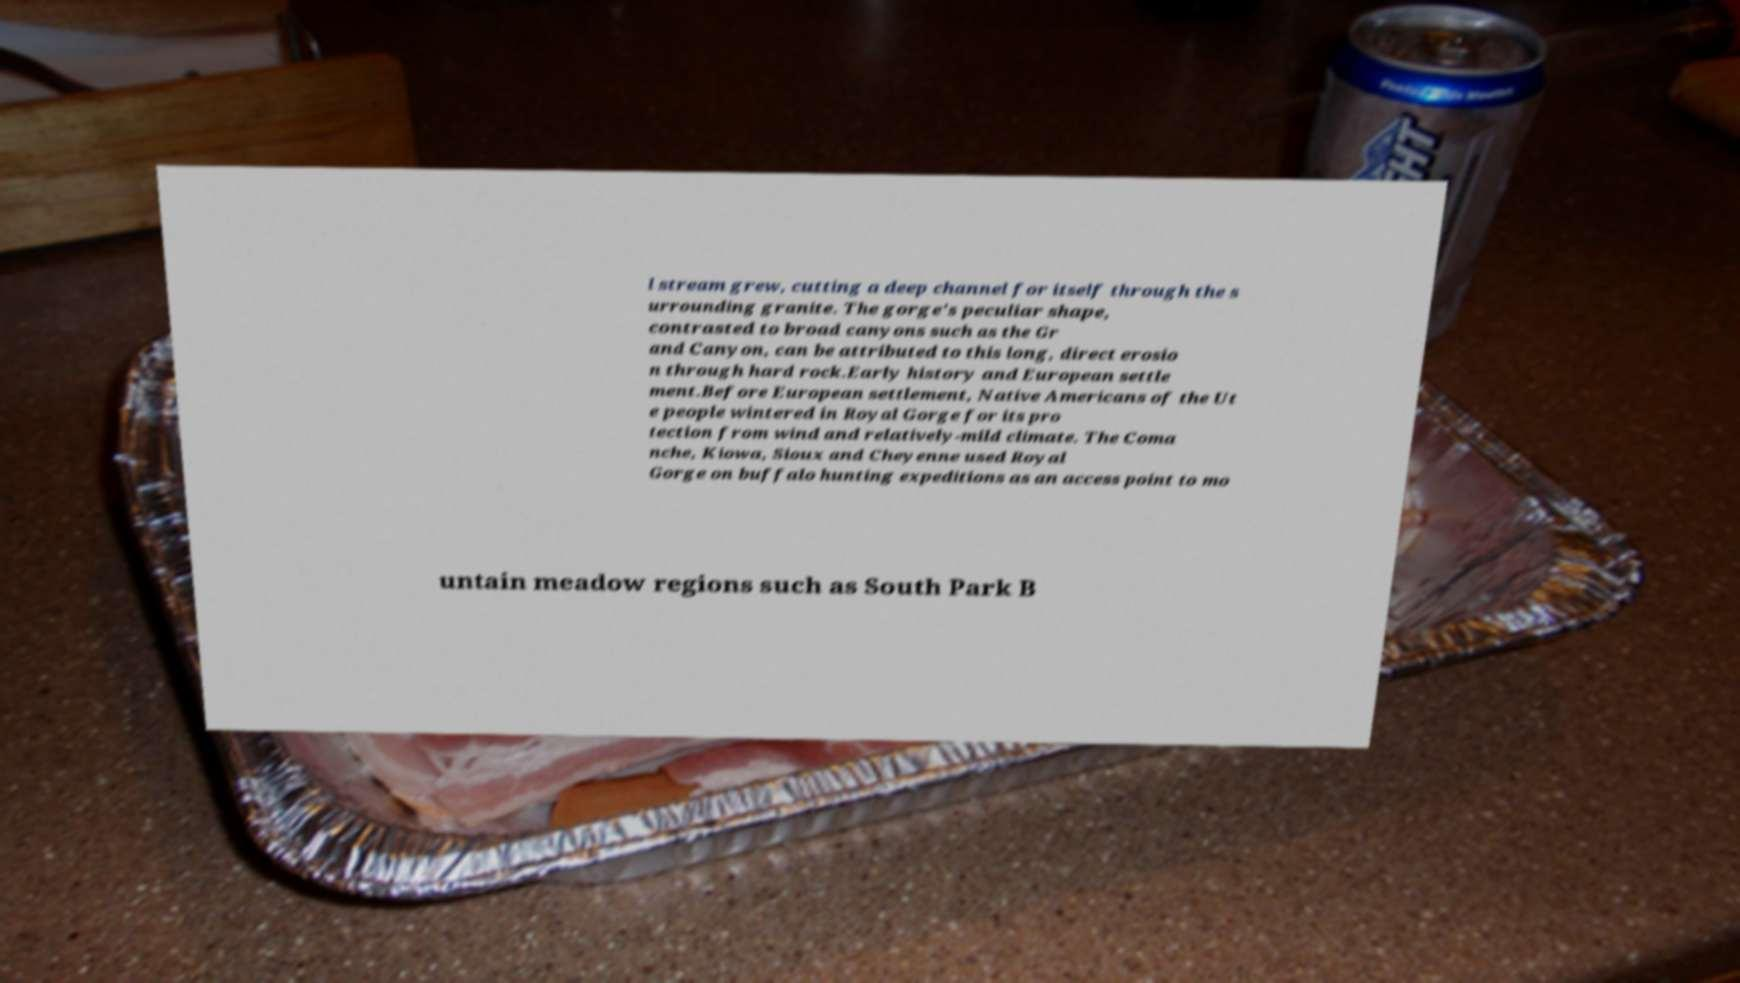Could you assist in decoding the text presented in this image and type it out clearly? l stream grew, cutting a deep channel for itself through the s urrounding granite. The gorge's peculiar shape, contrasted to broad canyons such as the Gr and Canyon, can be attributed to this long, direct erosio n through hard rock.Early history and European settle ment.Before European settlement, Native Americans of the Ut e people wintered in Royal Gorge for its pro tection from wind and relatively-mild climate. The Coma nche, Kiowa, Sioux and Cheyenne used Royal Gorge on buffalo hunting expeditions as an access point to mo untain meadow regions such as South Park B 